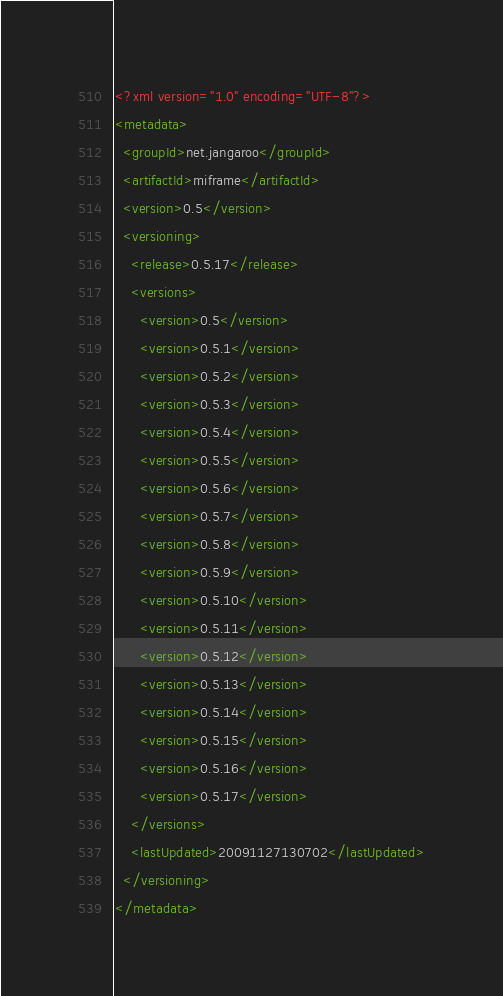<code> <loc_0><loc_0><loc_500><loc_500><_XML_><?xml version="1.0" encoding="UTF-8"?>
<metadata>
  <groupId>net.jangaroo</groupId>
  <artifactId>miframe</artifactId>
  <version>0.5</version>
  <versioning>
    <release>0.5.17</release>
    <versions>
      <version>0.5</version>
      <version>0.5.1</version>
      <version>0.5.2</version>
      <version>0.5.3</version>
      <version>0.5.4</version>
      <version>0.5.5</version>
      <version>0.5.6</version>
      <version>0.5.7</version>
      <version>0.5.8</version>
      <version>0.5.9</version>
      <version>0.5.10</version>
      <version>0.5.11</version>
      <version>0.5.12</version>
      <version>0.5.13</version>
      <version>0.5.14</version>
      <version>0.5.15</version>
      <version>0.5.16</version>
      <version>0.5.17</version>
    </versions>
    <lastUpdated>20091127130702</lastUpdated>
  </versioning>
</metadata>
</code> 